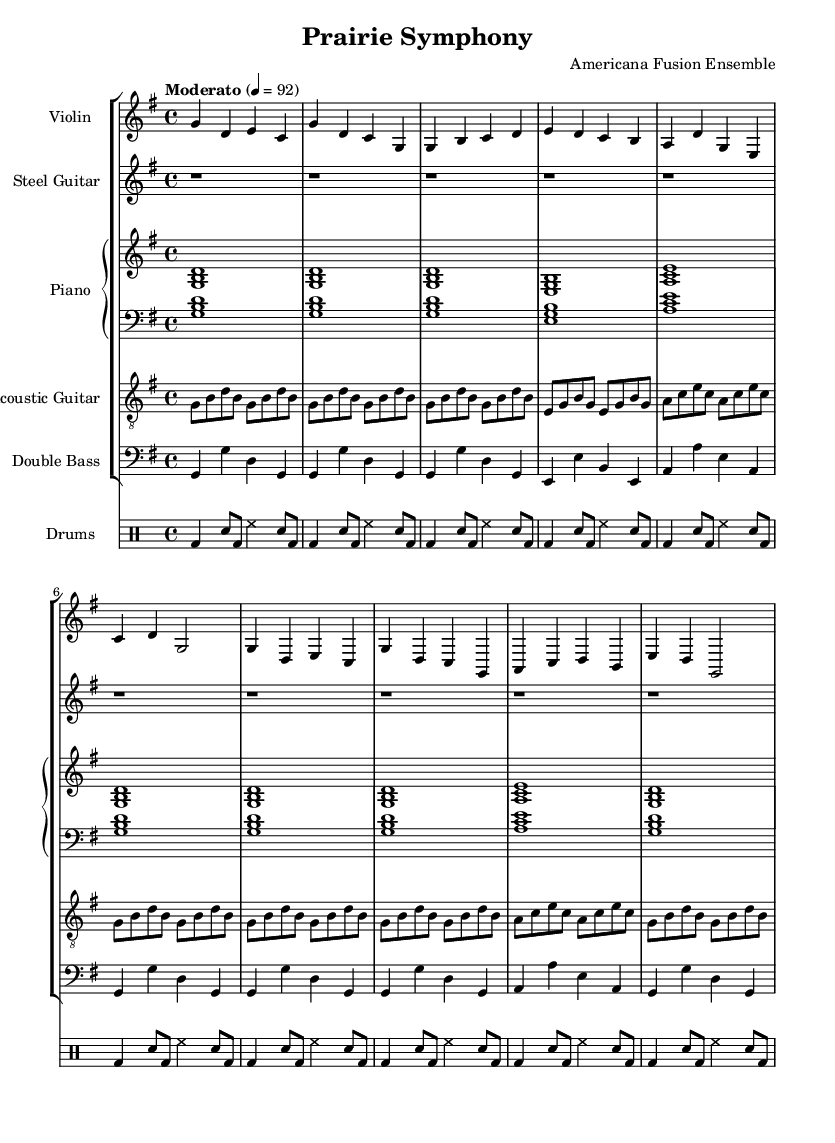What is the key signature of this music? The key signature shows one sharp, indicating that the piece is in G major.
Answer: G major What is the time signature of this music? The time signature appears at the beginning of the score, showing that it is in 4/4, which means there are four beats per measure.
Answer: 4/4 What is the tempo marking of this piece? The tempo marking can be found at the beginning, which specifies "Moderato" and indicates a speed of 92 beats per minute.
Answer: Moderato, 92 How many measures are in the violin part? The violin part contains 8 measures, as counted by the number of bar lines.
Answer: 8 How many instruments are featured in this score? By counting the unique staves, we find there are six distinct instruments: violin, steel guitar, piano, acoustic guitar, double bass, and drums.
Answer: Six What type of musical fusion is represented in this sheet music? This sheet music represents a modern country-classical fusion, as indicated by the title "Prairie Symphony" and the instrumentation used.
Answer: Modern country-classical fusion Which instrument has rests throughout the piece? The steel guitar part consists only of rests, as there are no notes written, indicating it doesn't contribute melodic material in this section.
Answer: Steel guitar 